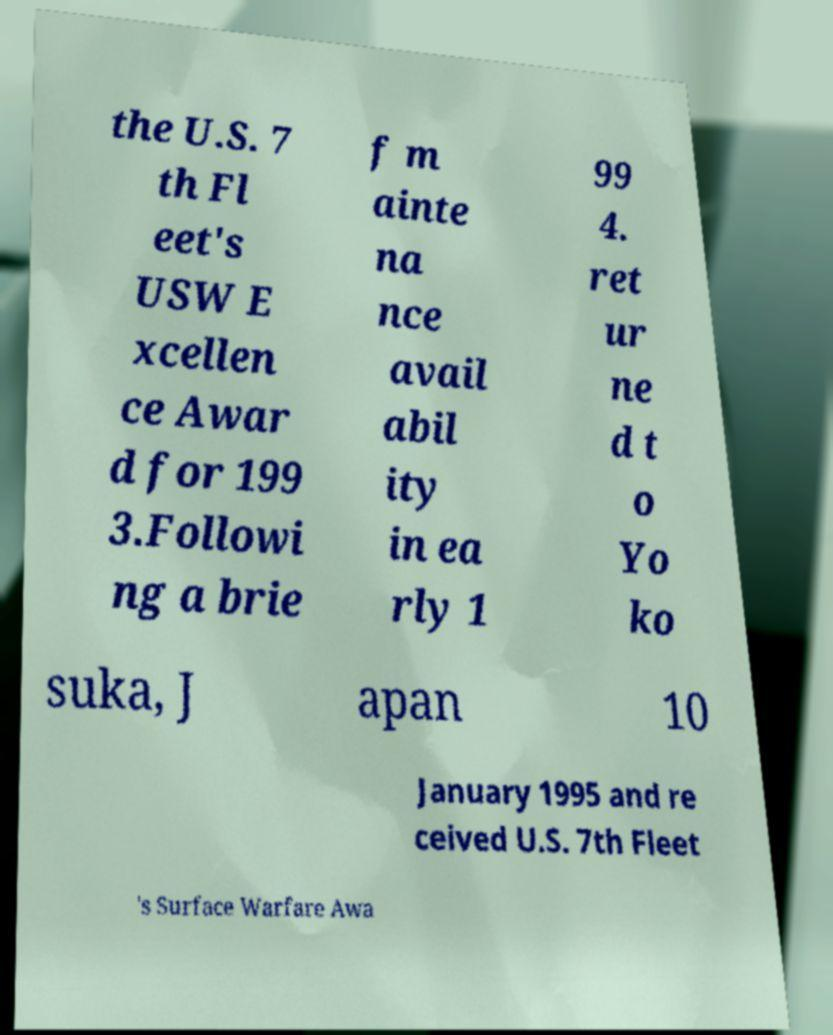I need the written content from this picture converted into text. Can you do that? the U.S. 7 th Fl eet's USW E xcellen ce Awar d for 199 3.Followi ng a brie f m ainte na nce avail abil ity in ea rly 1 99 4. ret ur ne d t o Yo ko suka, J apan 10 January 1995 and re ceived U.S. 7th Fleet 's Surface Warfare Awa 